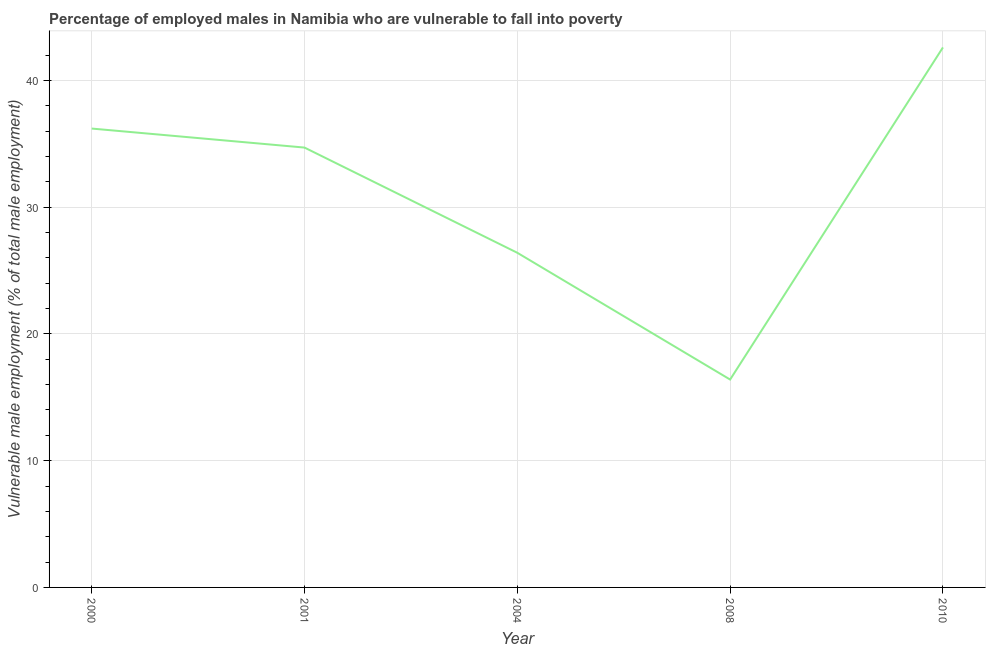What is the percentage of employed males who are vulnerable to fall into poverty in 2010?
Make the answer very short. 42.6. Across all years, what is the maximum percentage of employed males who are vulnerable to fall into poverty?
Offer a terse response. 42.6. Across all years, what is the minimum percentage of employed males who are vulnerable to fall into poverty?
Your answer should be very brief. 16.4. In which year was the percentage of employed males who are vulnerable to fall into poverty maximum?
Make the answer very short. 2010. In which year was the percentage of employed males who are vulnerable to fall into poverty minimum?
Your answer should be compact. 2008. What is the sum of the percentage of employed males who are vulnerable to fall into poverty?
Make the answer very short. 156.3. What is the difference between the percentage of employed males who are vulnerable to fall into poverty in 2000 and 2010?
Offer a very short reply. -6.4. What is the average percentage of employed males who are vulnerable to fall into poverty per year?
Ensure brevity in your answer.  31.26. What is the median percentage of employed males who are vulnerable to fall into poverty?
Ensure brevity in your answer.  34.7. Do a majority of the years between 2000 and 2008 (inclusive) have percentage of employed males who are vulnerable to fall into poverty greater than 16 %?
Your answer should be compact. Yes. What is the ratio of the percentage of employed males who are vulnerable to fall into poverty in 2001 to that in 2004?
Your answer should be compact. 1.31. Is the percentage of employed males who are vulnerable to fall into poverty in 2001 less than that in 2008?
Provide a succinct answer. No. Is the difference between the percentage of employed males who are vulnerable to fall into poverty in 2001 and 2010 greater than the difference between any two years?
Your response must be concise. No. What is the difference between the highest and the second highest percentage of employed males who are vulnerable to fall into poverty?
Offer a terse response. 6.4. What is the difference between the highest and the lowest percentage of employed males who are vulnerable to fall into poverty?
Ensure brevity in your answer.  26.2. How many lines are there?
Keep it short and to the point. 1. How many years are there in the graph?
Your answer should be very brief. 5. Are the values on the major ticks of Y-axis written in scientific E-notation?
Keep it short and to the point. No. What is the title of the graph?
Offer a terse response. Percentage of employed males in Namibia who are vulnerable to fall into poverty. What is the label or title of the Y-axis?
Offer a terse response. Vulnerable male employment (% of total male employment). What is the Vulnerable male employment (% of total male employment) of 2000?
Your response must be concise. 36.2. What is the Vulnerable male employment (% of total male employment) in 2001?
Your response must be concise. 34.7. What is the Vulnerable male employment (% of total male employment) in 2004?
Your response must be concise. 26.4. What is the Vulnerable male employment (% of total male employment) of 2008?
Offer a terse response. 16.4. What is the Vulnerable male employment (% of total male employment) in 2010?
Make the answer very short. 42.6. What is the difference between the Vulnerable male employment (% of total male employment) in 2000 and 2001?
Give a very brief answer. 1.5. What is the difference between the Vulnerable male employment (% of total male employment) in 2000 and 2008?
Keep it short and to the point. 19.8. What is the difference between the Vulnerable male employment (% of total male employment) in 2000 and 2010?
Make the answer very short. -6.4. What is the difference between the Vulnerable male employment (% of total male employment) in 2004 and 2008?
Keep it short and to the point. 10. What is the difference between the Vulnerable male employment (% of total male employment) in 2004 and 2010?
Offer a terse response. -16.2. What is the difference between the Vulnerable male employment (% of total male employment) in 2008 and 2010?
Provide a succinct answer. -26.2. What is the ratio of the Vulnerable male employment (% of total male employment) in 2000 to that in 2001?
Give a very brief answer. 1.04. What is the ratio of the Vulnerable male employment (% of total male employment) in 2000 to that in 2004?
Offer a very short reply. 1.37. What is the ratio of the Vulnerable male employment (% of total male employment) in 2000 to that in 2008?
Keep it short and to the point. 2.21. What is the ratio of the Vulnerable male employment (% of total male employment) in 2001 to that in 2004?
Your response must be concise. 1.31. What is the ratio of the Vulnerable male employment (% of total male employment) in 2001 to that in 2008?
Your answer should be compact. 2.12. What is the ratio of the Vulnerable male employment (% of total male employment) in 2001 to that in 2010?
Offer a very short reply. 0.81. What is the ratio of the Vulnerable male employment (% of total male employment) in 2004 to that in 2008?
Make the answer very short. 1.61. What is the ratio of the Vulnerable male employment (% of total male employment) in 2004 to that in 2010?
Your answer should be compact. 0.62. What is the ratio of the Vulnerable male employment (% of total male employment) in 2008 to that in 2010?
Your answer should be very brief. 0.39. 